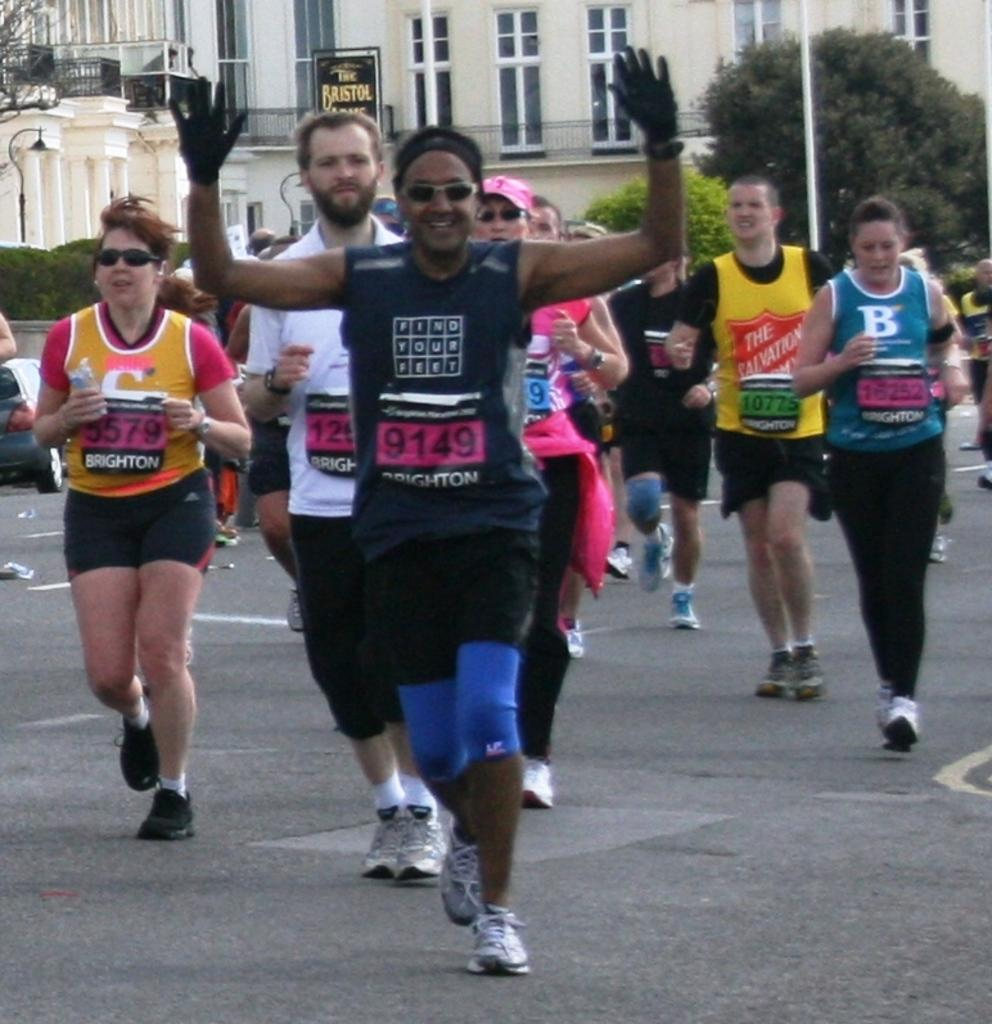How many persons are in the image? There are persons in the image, but the exact number is not specified. What can be observed about the dresses of the persons in the image? The persons are in different color dresses. What are the persons in the image doing? The persons are running on the road. Can you describe the expressions of the persons in the image? Some of the persons are smiling. What is visible in the background of the image? There are trees, plants, and buildings in the background of the image. What type of produce can be seen in the image? There is no produce visible in the image. How many passengers are in the image? The term "passenger" is not relevant to the image, as it features persons running on a road. 